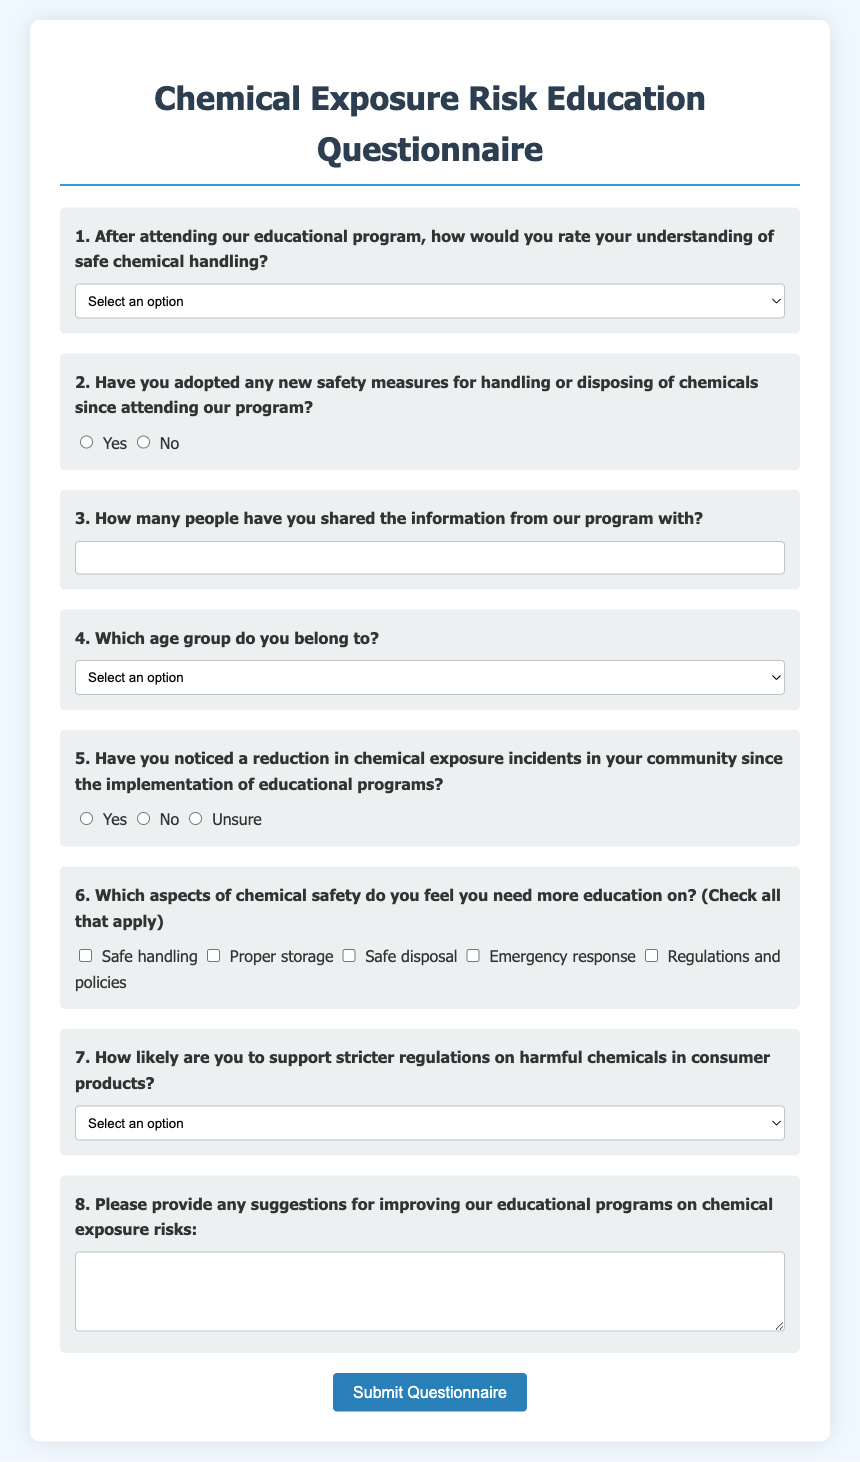What is the title of the questionnaire? The title of the questionnaire is found at the top of the document, which is "Chemical Exposure Risk Education Questionnaire."
Answer: Chemical Exposure Risk Education Questionnaire How many questions are there in the questionnaire? The document contains a form with a total of 8 questions.
Answer: 8 What age group option is provided for respondents under 18? The questionnaire includes options for age groups, with the specific one for respondents under 18 labeled as "Under 18."
Answer: Under 18 What type of input is used for question 3? Question 3 asks respondents to input a number and uses an input field for that purpose.
Answer: Input field What is the highest rating given for understanding safe chemical handling? The highest rating on the scale provided for understanding safe chemical handling is "Excellent improvement."
Answer: Excellent improvement Which aspect of chemical safety has an option for "Emergency response"? The questionnaire asks about which aspects of chemical safety need more education, and "Emergency response" is one of the checkbox options.
Answer: Emergency response How should respondents submit the questionnaire? There is a button at the end of the questionnaire for respondents to click and submit their answers.
Answer: Submit button What response options are available for question 5 regarding incident reduction? The available options for question 5 are "Yes," "No," and "Unsure."
Answer: Yes, No, Unsure 